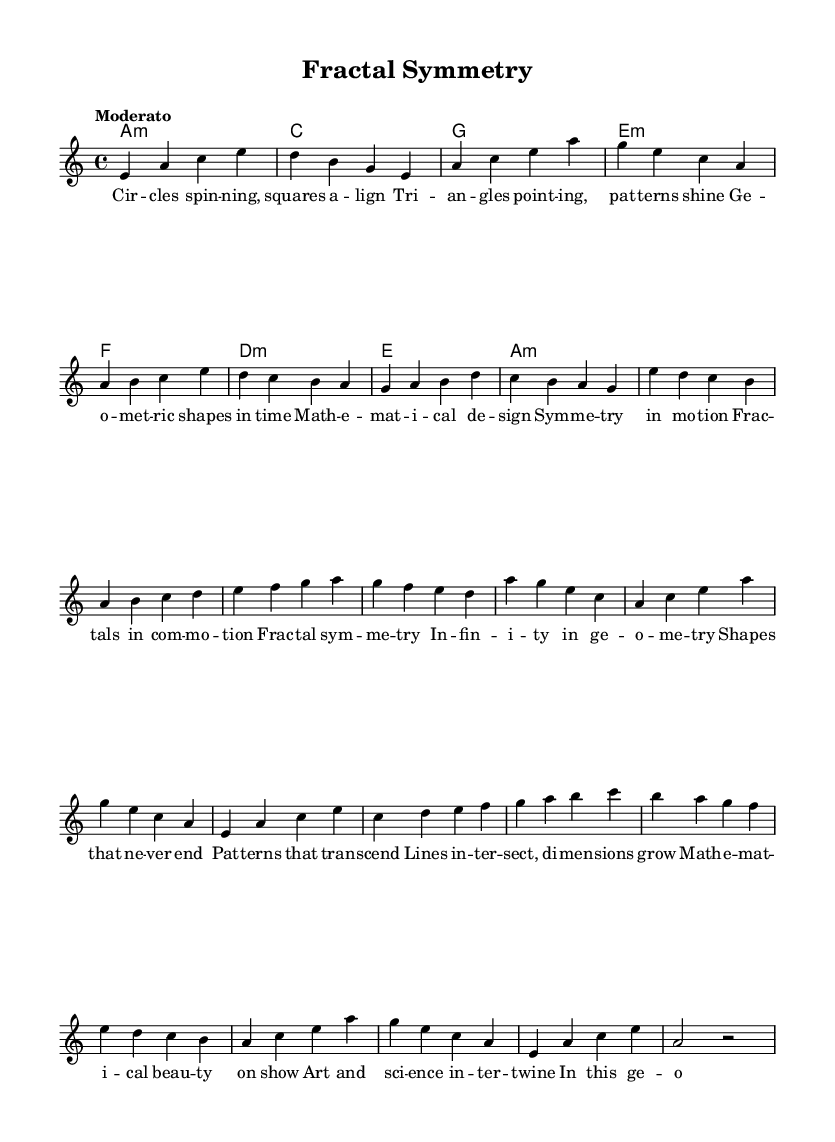What is the key signature of this music? The key signature can be found at the beginning of the staff, which indicates it is in A minor, as there is no indication of sharps or flats in the signature.
Answer: A minor What is the time signature of this music? The time signature, located next to the key signature at the beginning of the piece, is 4/4, indicating that there are four beats in each measure and each quarter note gets one beat.
Answer: 4/4 What is the tempo marking of this music? The tempo marking appears at the beginning of the score and states "Moderato," referring to a moderate speed of the music, which is a common tempo indication.
Answer: Moderato How many measures are in the chorus section? By analyzing the sheet music, the chorus section can be located after the Pre-Chorus and consists of four measures, each marked in the score.
Answer: 4 What type of chords are used in the harmonies section? The chord symbols in the harmonies section indicate that the chords used are mainly triads and seventh chords, specifically including minor, major, and a minor chord.
Answer: A minor, C, G, E minor, F, D minor In which section does the phrase "Fractal symmetry" appear? By inspecting the lyrics aligned with the melody, the phrase "Fractal symmetry" is found in the chorus section of the song, which highlights the central theme of the piece.
Answer: Chorus What is the central theme of the lyrics? The lyrics express concepts related to geometry, symmetry, and the beauty of mathematical patterns, emphasizing the intersection of art and mathematics as its central theme.
Answer: Geometric patterns and shapes 